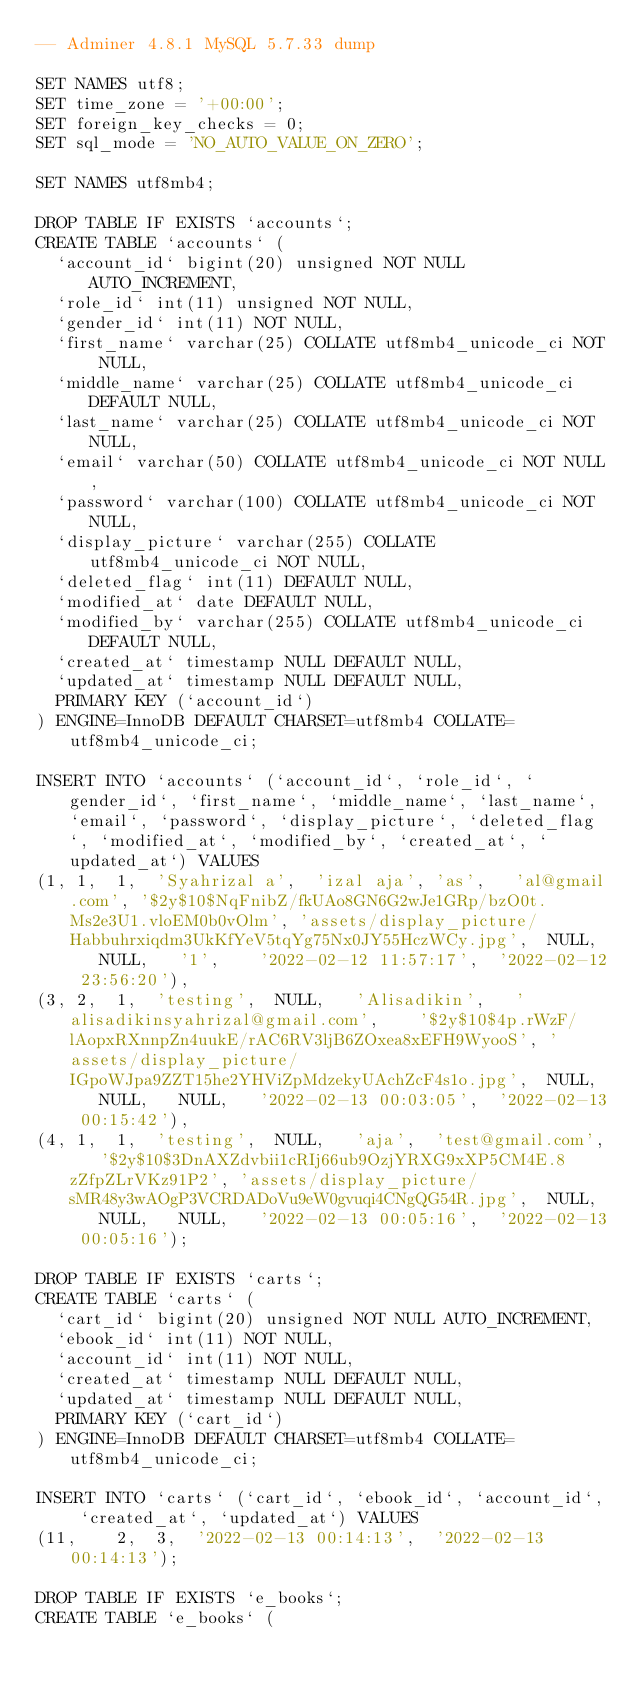<code> <loc_0><loc_0><loc_500><loc_500><_SQL_>-- Adminer 4.8.1 MySQL 5.7.33 dump

SET NAMES utf8;
SET time_zone = '+00:00';
SET foreign_key_checks = 0;
SET sql_mode = 'NO_AUTO_VALUE_ON_ZERO';

SET NAMES utf8mb4;

DROP TABLE IF EXISTS `accounts`;
CREATE TABLE `accounts` (
  `account_id` bigint(20) unsigned NOT NULL AUTO_INCREMENT,
  `role_id` int(11) unsigned NOT NULL,
  `gender_id` int(11) NOT NULL,
  `first_name` varchar(25) COLLATE utf8mb4_unicode_ci NOT NULL,
  `middle_name` varchar(25) COLLATE utf8mb4_unicode_ci DEFAULT NULL,
  `last_name` varchar(25) COLLATE utf8mb4_unicode_ci NOT NULL,
  `email` varchar(50) COLLATE utf8mb4_unicode_ci NOT NULL,
  `password` varchar(100) COLLATE utf8mb4_unicode_ci NOT NULL,
  `display_picture` varchar(255) COLLATE utf8mb4_unicode_ci NOT NULL,
  `deleted_flag` int(11) DEFAULT NULL,
  `modified_at` date DEFAULT NULL,
  `modified_by` varchar(255) COLLATE utf8mb4_unicode_ci DEFAULT NULL,
  `created_at` timestamp NULL DEFAULT NULL,
  `updated_at` timestamp NULL DEFAULT NULL,
  PRIMARY KEY (`account_id`)
) ENGINE=InnoDB DEFAULT CHARSET=utf8mb4 COLLATE=utf8mb4_unicode_ci;

INSERT INTO `accounts` (`account_id`, `role_id`, `gender_id`, `first_name`, `middle_name`, `last_name`, `email`, `password`, `display_picture`, `deleted_flag`, `modified_at`, `modified_by`, `created_at`, `updated_at`) VALUES
(1,	1,	1,	'Syahrizal a',	'izal aja',	'as',	'al@gmail.com',	'$2y$10$NqFnibZ/fkUAo8GN6G2wJe1GRp/bzO0t.Ms2e3U1.vloEM0b0vOlm',	'assets/display_picture/Habbuhrxiqdm3UkKfYeV5tqYg75Nx0JY55HczWCy.jpg',	NULL,	NULL,	'1',	'2022-02-12 11:57:17',	'2022-02-12 23:56:20'),
(3,	2,	1,	'testing',	NULL,	'Alisadikin',	'alisadikinsyahrizal@gmail.com',	'$2y$10$4p.rWzF/lAopxRXnnpZn4uukE/rAC6RV3ljB6ZOxea8xEFH9WyooS',	'assets/display_picture/IGpoWJpa9ZZT15he2YHViZpMdzekyUAchZcF4s1o.jpg',	NULL,	NULL,	NULL,	'2022-02-13 00:03:05',	'2022-02-13 00:15:42'),
(4,	1,	1,	'testing',	NULL,	'aja',	'test@gmail.com',	'$2y$10$3DnAXZdvbii1cRIj66ub9OzjYRXG9xXP5CM4E.8zZfpZLrVKz91P2',	'assets/display_picture/sMR48y3wAOgP3VCRDADoVu9eW0gvuqi4CNgQG54R.jpg',	NULL,	NULL,	NULL,	'2022-02-13 00:05:16',	'2022-02-13 00:05:16');

DROP TABLE IF EXISTS `carts`;
CREATE TABLE `carts` (
  `cart_id` bigint(20) unsigned NOT NULL AUTO_INCREMENT,
  `ebook_id` int(11) NOT NULL,
  `account_id` int(11) NOT NULL,
  `created_at` timestamp NULL DEFAULT NULL,
  `updated_at` timestamp NULL DEFAULT NULL,
  PRIMARY KEY (`cart_id`)
) ENGINE=InnoDB DEFAULT CHARSET=utf8mb4 COLLATE=utf8mb4_unicode_ci;

INSERT INTO `carts` (`cart_id`, `ebook_id`, `account_id`, `created_at`, `updated_at`) VALUES
(11,	2,	3,	'2022-02-13 00:14:13',	'2022-02-13 00:14:13');

DROP TABLE IF EXISTS `e_books`;
CREATE TABLE `e_books` (</code> 